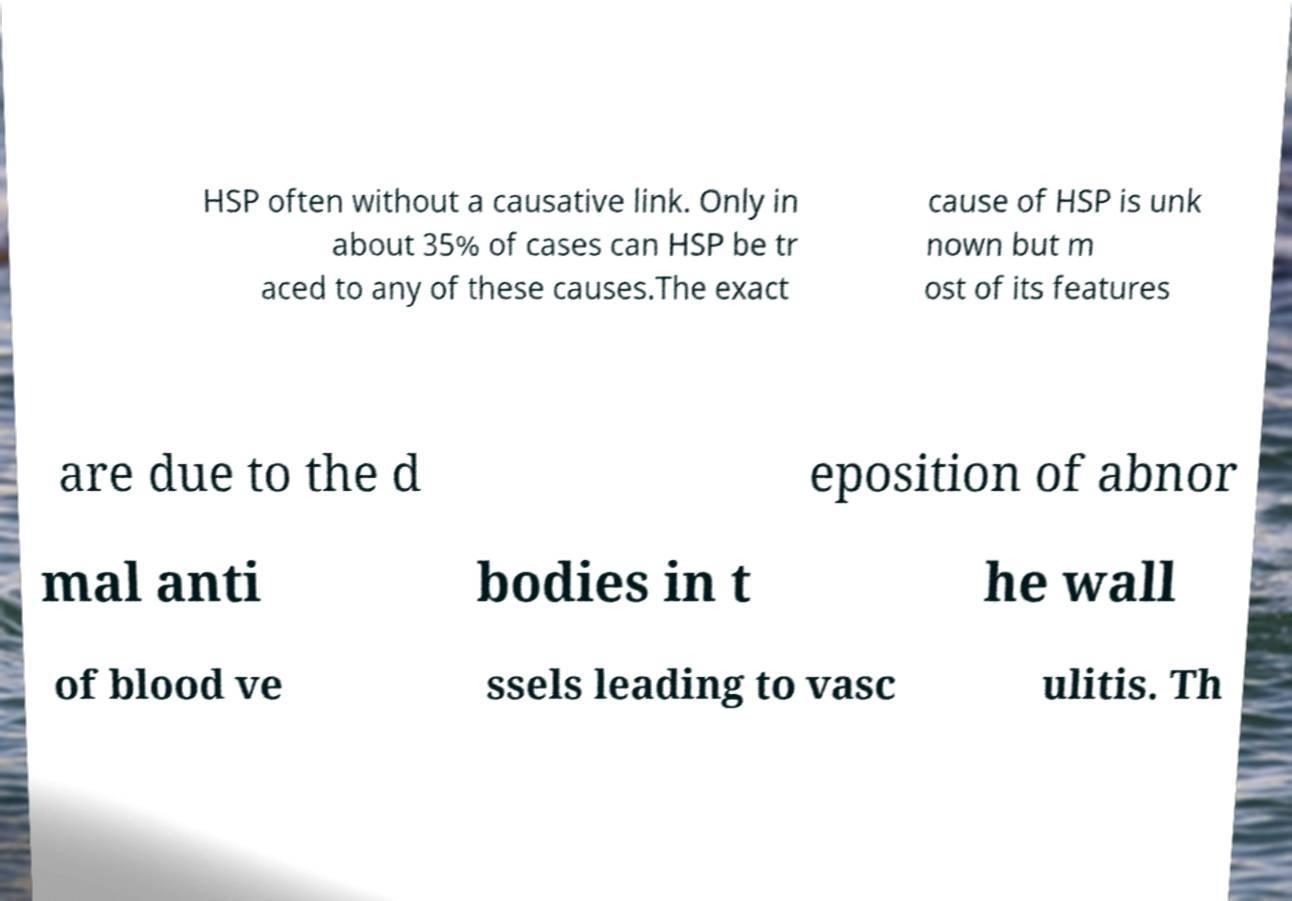Could you assist in decoding the text presented in this image and type it out clearly? HSP often without a causative link. Only in about 35% of cases can HSP be tr aced to any of these causes.The exact cause of HSP is unk nown but m ost of its features are due to the d eposition of abnor mal anti bodies in t he wall of blood ve ssels leading to vasc ulitis. Th 